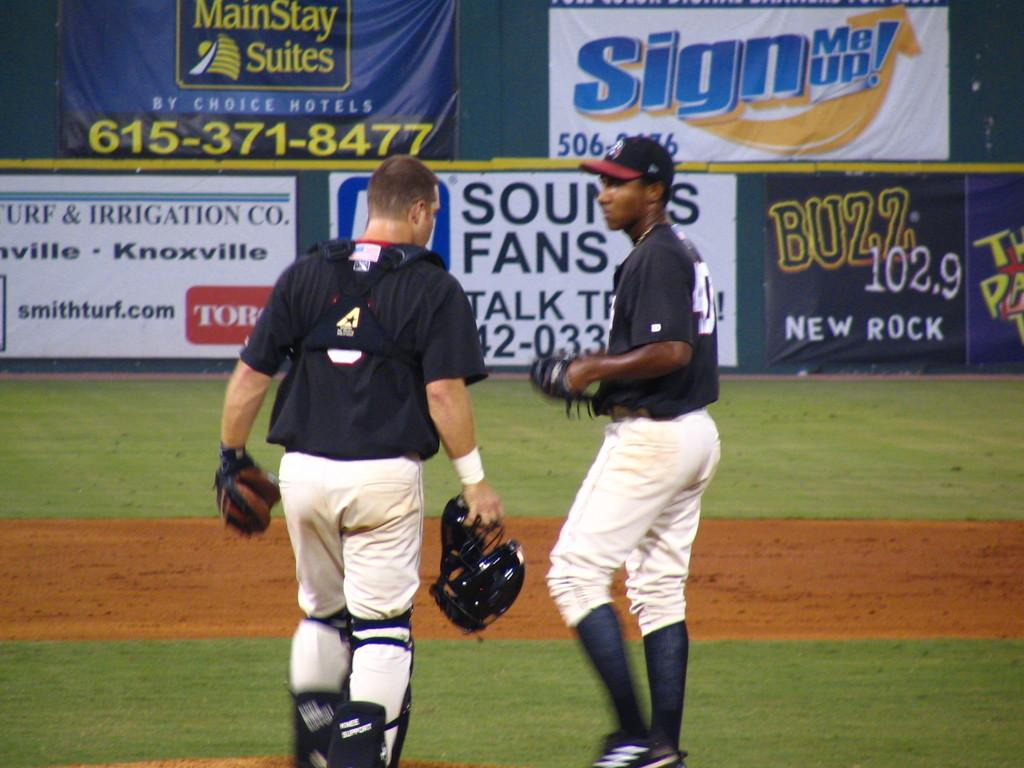<image>
Present a compact description of the photo's key features. Two baseball players talk while standing in front signs for Buzz 102.9 New Rock and  MainStay Suites. 